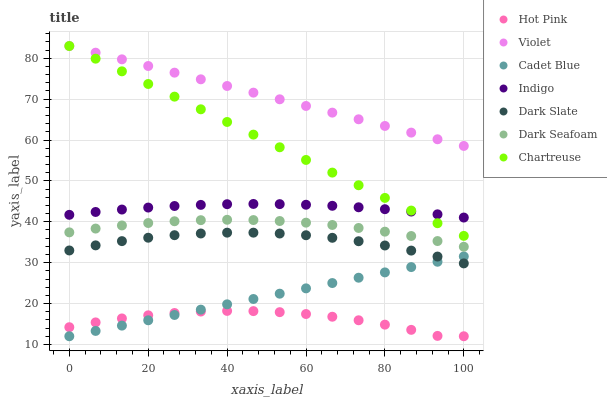Does Hot Pink have the minimum area under the curve?
Answer yes or no. Yes. Does Violet have the maximum area under the curve?
Answer yes or no. Yes. Does Indigo have the minimum area under the curve?
Answer yes or no. No. Does Indigo have the maximum area under the curve?
Answer yes or no. No. Is Cadet Blue the smoothest?
Answer yes or no. Yes. Is Hot Pink the roughest?
Answer yes or no. Yes. Is Indigo the smoothest?
Answer yes or no. No. Is Indigo the roughest?
Answer yes or no. No. Does Cadet Blue have the lowest value?
Answer yes or no. Yes. Does Indigo have the lowest value?
Answer yes or no. No. Does Violet have the highest value?
Answer yes or no. Yes. Does Indigo have the highest value?
Answer yes or no. No. Is Cadet Blue less than Violet?
Answer yes or no. Yes. Is Dark Seafoam greater than Cadet Blue?
Answer yes or no. Yes. Does Hot Pink intersect Cadet Blue?
Answer yes or no. Yes. Is Hot Pink less than Cadet Blue?
Answer yes or no. No. Is Hot Pink greater than Cadet Blue?
Answer yes or no. No. Does Cadet Blue intersect Violet?
Answer yes or no. No. 